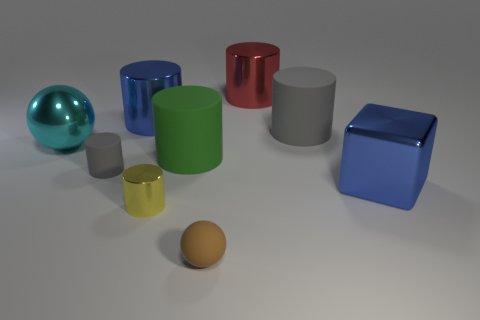There is a tiny ball that is the same material as the green cylinder; what is its color?
Your answer should be compact. Brown. Is the number of tiny gray cylinders that are in front of the blue block greater than the number of cylinders right of the large red cylinder?
Your response must be concise. No. Are there any brown metal cubes?
Your answer should be very brief. No. There is a large thing that is the same color as the block; what is its material?
Make the answer very short. Metal. How many objects are red objects or balls?
Your answer should be compact. 3. Is there a tiny ball of the same color as the tiny metallic object?
Your answer should be compact. No. How many tiny brown rubber objects are to the left of the small cylinder behind the yellow thing?
Your answer should be very brief. 0. Is the number of small shiny cylinders greater than the number of large purple metallic balls?
Keep it short and to the point. Yes. Do the large green cylinder and the large gray cylinder have the same material?
Your response must be concise. Yes. Are there an equal number of small gray matte cylinders right of the tiny metal thing and tiny gray rubber things?
Offer a terse response. No. 